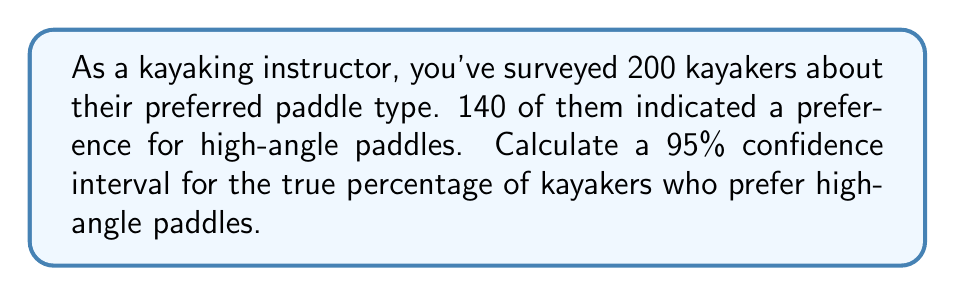Provide a solution to this math problem. Let's approach this step-by-step:

1) First, we need to calculate the sample proportion:
   $\hat{p} = \frac{140}{200} = 0.7$ or 70%

2) The formula for the confidence interval is:
   $$\hat{p} \pm z_{\alpha/2} \sqrt{\frac{\hat{p}(1-\hat{p})}{n}}$$
   where $z_{\alpha/2}$ is the critical value for the desired confidence level.

3) For a 95% confidence interval, $z_{\alpha/2} = 1.96$

4) Now, let's substitute our values:
   $n = 200$
   $\hat{p} = 0.7$

5) Calculate the standard error:
   $$SE = \sqrt{\frac{\hat{p}(1-\hat{p})}{n}} = \sqrt{\frac{0.7(1-0.7)}{200}} = \sqrt{\frac{0.21}{200}} = 0.0324$$

6) Now we can calculate the margin of error:
   $$ME = 1.96 * 0.0324 = 0.0635$$

7) Finally, we can compute the confidence interval:
   Lower bound: $0.7 - 0.0635 = 0.6365$ or 63.65%
   Upper bound: $0.7 + 0.0635 = 0.7635$ or 76.35%

Therefore, we are 95% confident that the true percentage of kayakers who prefer high-angle paddles is between 63.65% and 76.35%.
Answer: (63.65%, 76.35%) 